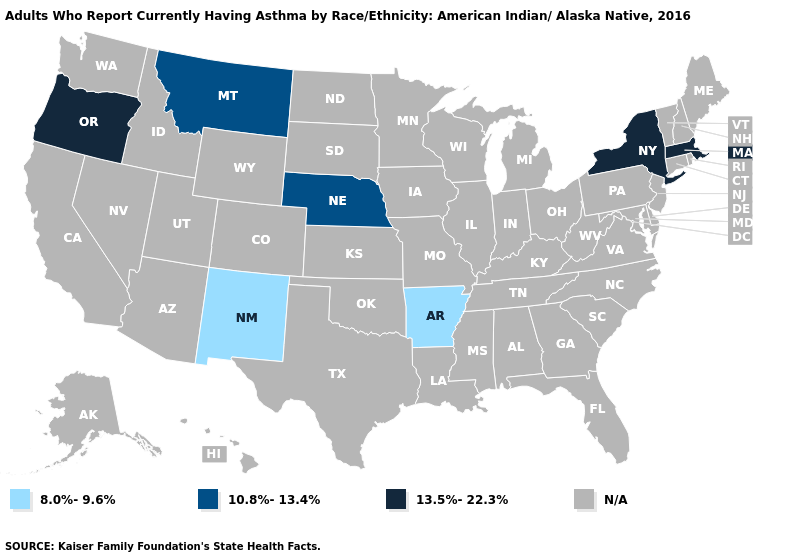Which states hav the highest value in the West?
Quick response, please. Oregon. What is the value of Mississippi?
Concise answer only. N/A. Name the states that have a value in the range 13.5%-22.3%?
Be succinct. Massachusetts, New York, Oregon. Name the states that have a value in the range N/A?
Keep it brief. Alabama, Alaska, Arizona, California, Colorado, Connecticut, Delaware, Florida, Georgia, Hawaii, Idaho, Illinois, Indiana, Iowa, Kansas, Kentucky, Louisiana, Maine, Maryland, Michigan, Minnesota, Mississippi, Missouri, Nevada, New Hampshire, New Jersey, North Carolina, North Dakota, Ohio, Oklahoma, Pennsylvania, Rhode Island, South Carolina, South Dakota, Tennessee, Texas, Utah, Vermont, Virginia, Washington, West Virginia, Wisconsin, Wyoming. Does New Mexico have the lowest value in the West?
Short answer required. Yes. What is the value of Pennsylvania?
Short answer required. N/A. What is the value of Tennessee?
Concise answer only. N/A. What is the value of Ohio?
Keep it brief. N/A. Which states have the lowest value in the South?
Be succinct. Arkansas. 